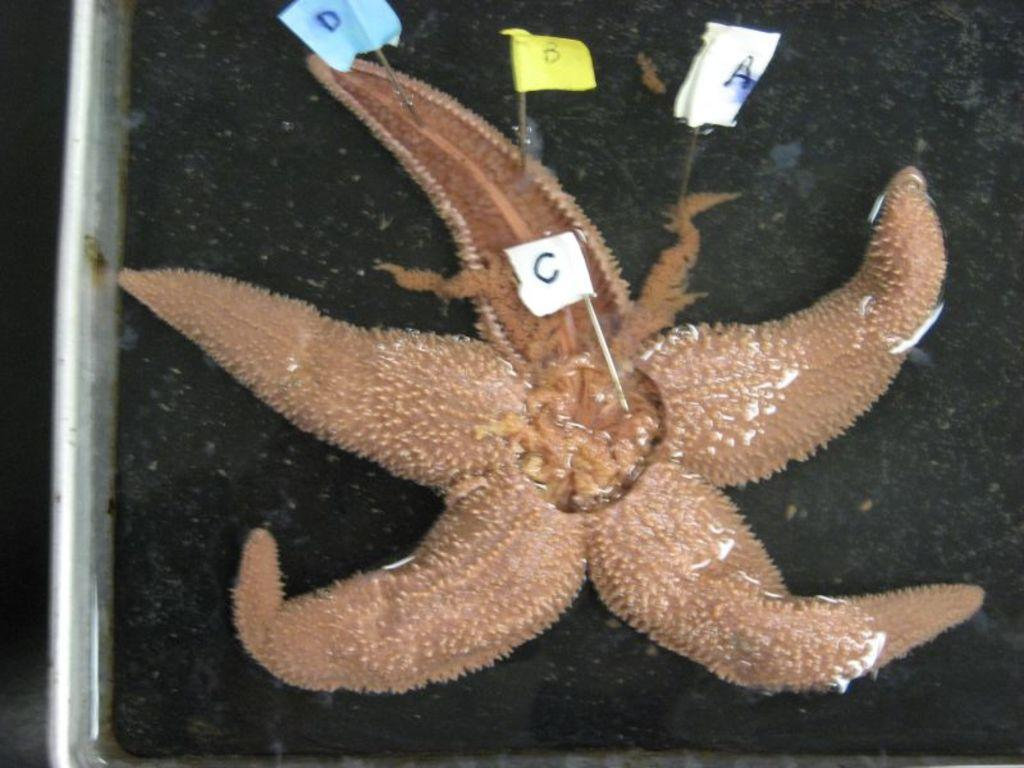What is the main subject of the image? The main subject of the image is a starfish. What is unique about the starfish in the image? The starfish has sticks on it. Is there any text visible in the image? Yes, there is a paper with text on the starfish. Where is the starfish located in the image? The starfish is on a tray. What type of noise can be heard coming from the starfish in the image? There is no noise coming from the starfish in the image, as it is a still image and not a video or audio recording. 